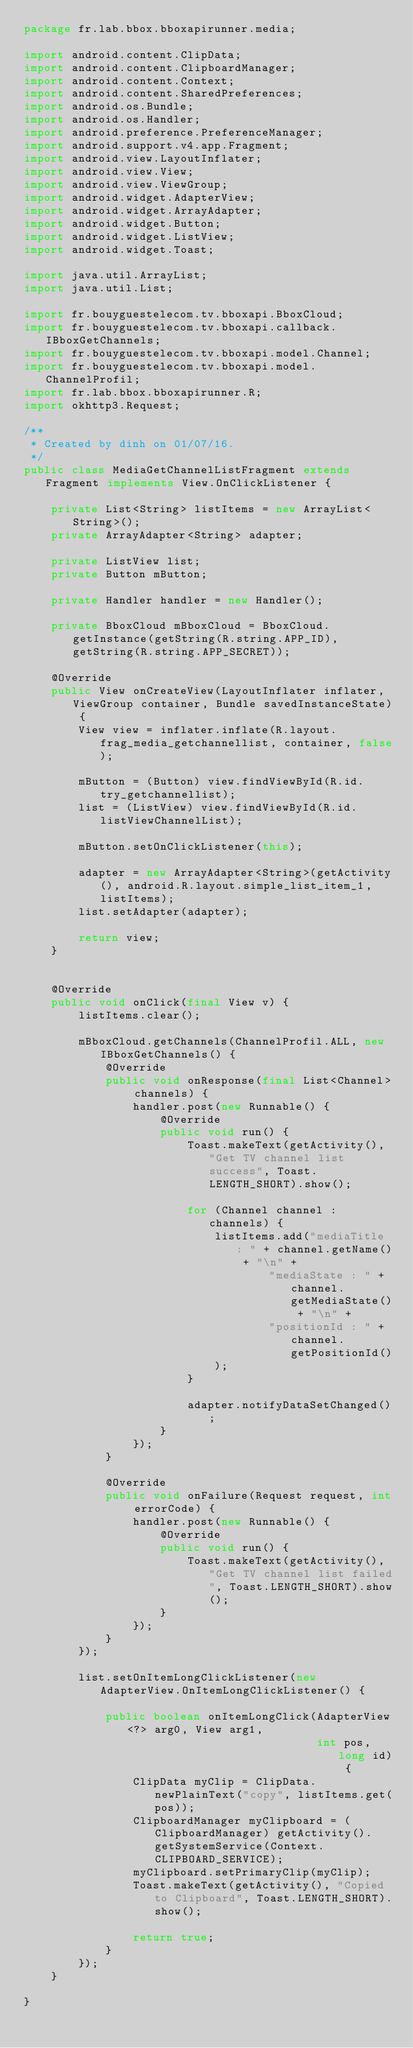<code> <loc_0><loc_0><loc_500><loc_500><_Java_>package fr.lab.bbox.bboxapirunner.media;

import android.content.ClipData;
import android.content.ClipboardManager;
import android.content.Context;
import android.content.SharedPreferences;
import android.os.Bundle;
import android.os.Handler;
import android.preference.PreferenceManager;
import android.support.v4.app.Fragment;
import android.view.LayoutInflater;
import android.view.View;
import android.view.ViewGroup;
import android.widget.AdapterView;
import android.widget.ArrayAdapter;
import android.widget.Button;
import android.widget.ListView;
import android.widget.Toast;

import java.util.ArrayList;
import java.util.List;

import fr.bouyguestelecom.tv.bboxapi.BboxCloud;
import fr.bouyguestelecom.tv.bboxapi.callback.IBboxGetChannels;
import fr.bouyguestelecom.tv.bboxapi.model.Channel;
import fr.bouyguestelecom.tv.bboxapi.model.ChannelProfil;
import fr.lab.bbox.bboxapirunner.R;
import okhttp3.Request;

/**
 * Created by dinh on 01/07/16.
 */
public class MediaGetChannelListFragment extends Fragment implements View.OnClickListener {

    private List<String> listItems = new ArrayList<String>();
    private ArrayAdapter<String> adapter;

    private ListView list;
    private Button mButton;

    private Handler handler = new Handler();

    private BboxCloud mBboxCloud = BboxCloud.getInstance(getString(R.string.APP_ID), getString(R.string.APP_SECRET));

    @Override
    public View onCreateView(LayoutInflater inflater, ViewGroup container, Bundle savedInstanceState) {
        View view = inflater.inflate(R.layout.frag_media_getchannellist, container, false);

        mButton = (Button) view.findViewById(R.id.try_getchannellist);
        list = (ListView) view.findViewById(R.id.listViewChannelList);

        mButton.setOnClickListener(this);

        adapter = new ArrayAdapter<String>(getActivity(), android.R.layout.simple_list_item_1, listItems);
        list.setAdapter(adapter);

        return view;
    }


    @Override
    public void onClick(final View v) {
        listItems.clear();

        mBboxCloud.getChannels(ChannelProfil.ALL, new IBboxGetChannels() {
            @Override
            public void onResponse(final List<Channel> channels) {
                handler.post(new Runnable() {
                    @Override
                    public void run() {
                        Toast.makeText(getActivity(), "Get TV channel list success", Toast.LENGTH_SHORT).show();

                        for (Channel channel : channels) {
                            listItems.add("mediaTitle : " + channel.getName() + "\n" +
                                    "mediaState : " + channel.getMediaState() + "\n" +
                                    "positionId : " + channel.getPositionId()
                            );
                        }

                        adapter.notifyDataSetChanged();
                    }
                });
            }

            @Override
            public void onFailure(Request request, int errorCode) {
                handler.post(new Runnable() {
                    @Override
                    public void run() {
                        Toast.makeText(getActivity(), "Get TV channel list failed", Toast.LENGTH_SHORT).show();
                    }
                });
            }
        });

        list.setOnItemLongClickListener(new AdapterView.OnItemLongClickListener() {

            public boolean onItemLongClick(AdapterView<?> arg0, View arg1,
                                           int pos, long id) {
                ClipData myClip = ClipData.newPlainText("copy", listItems.get(pos));
                ClipboardManager myClipboard = (ClipboardManager) getActivity().getSystemService(Context.CLIPBOARD_SERVICE);
                myClipboard.setPrimaryClip(myClip);
                Toast.makeText(getActivity(), "Copied to Clipboard", Toast.LENGTH_SHORT).show();

                return true;
            }
        });
    }

}</code> 